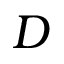Convert formula to latex. <formula><loc_0><loc_0><loc_500><loc_500>D</formula> 